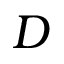Convert formula to latex. <formula><loc_0><loc_0><loc_500><loc_500>D</formula> 